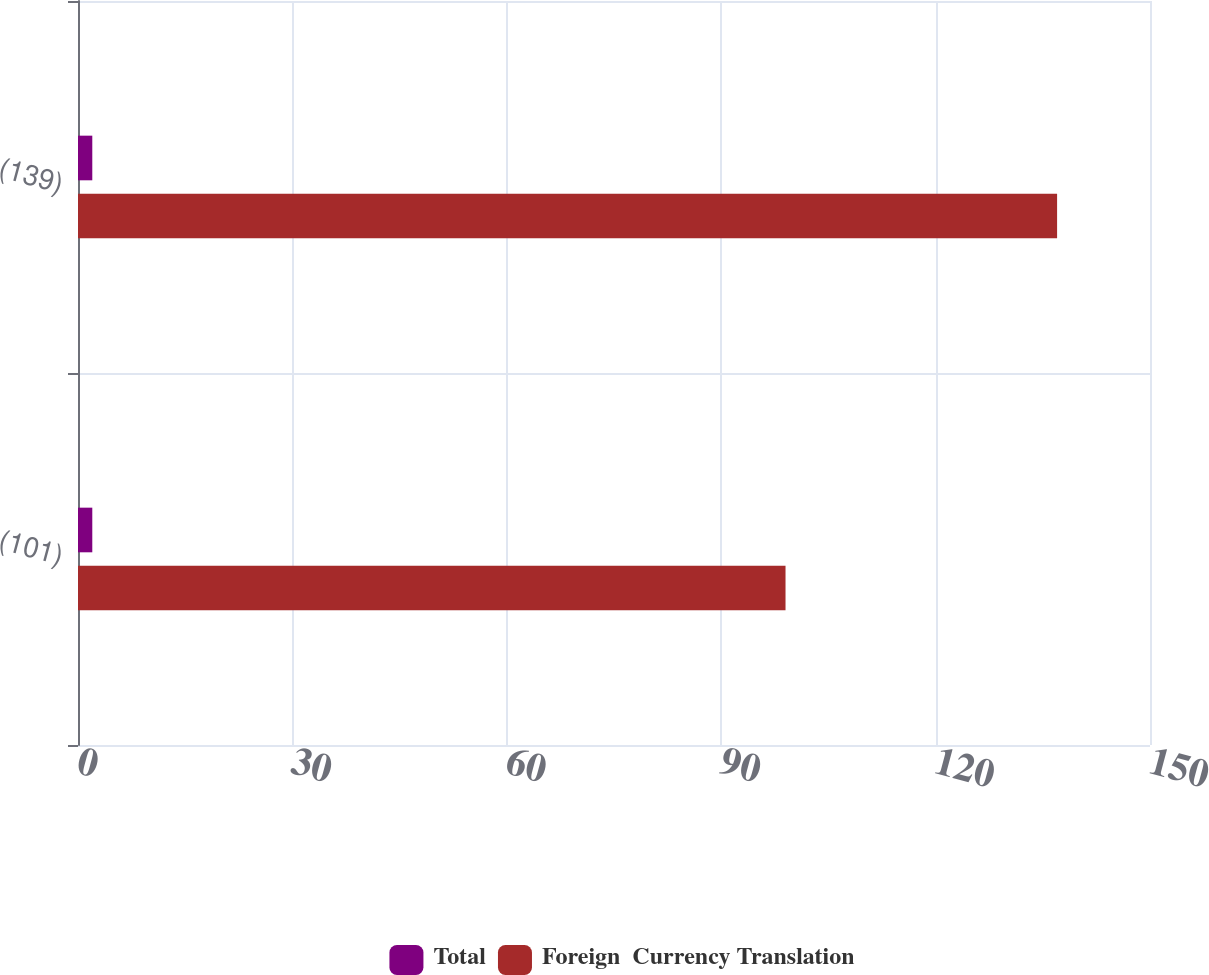Convert chart. <chart><loc_0><loc_0><loc_500><loc_500><stacked_bar_chart><ecel><fcel>(101)<fcel>(139)<nl><fcel>Total<fcel>2<fcel>2<nl><fcel>Foreign  Currency Translation<fcel>99<fcel>137<nl></chart> 